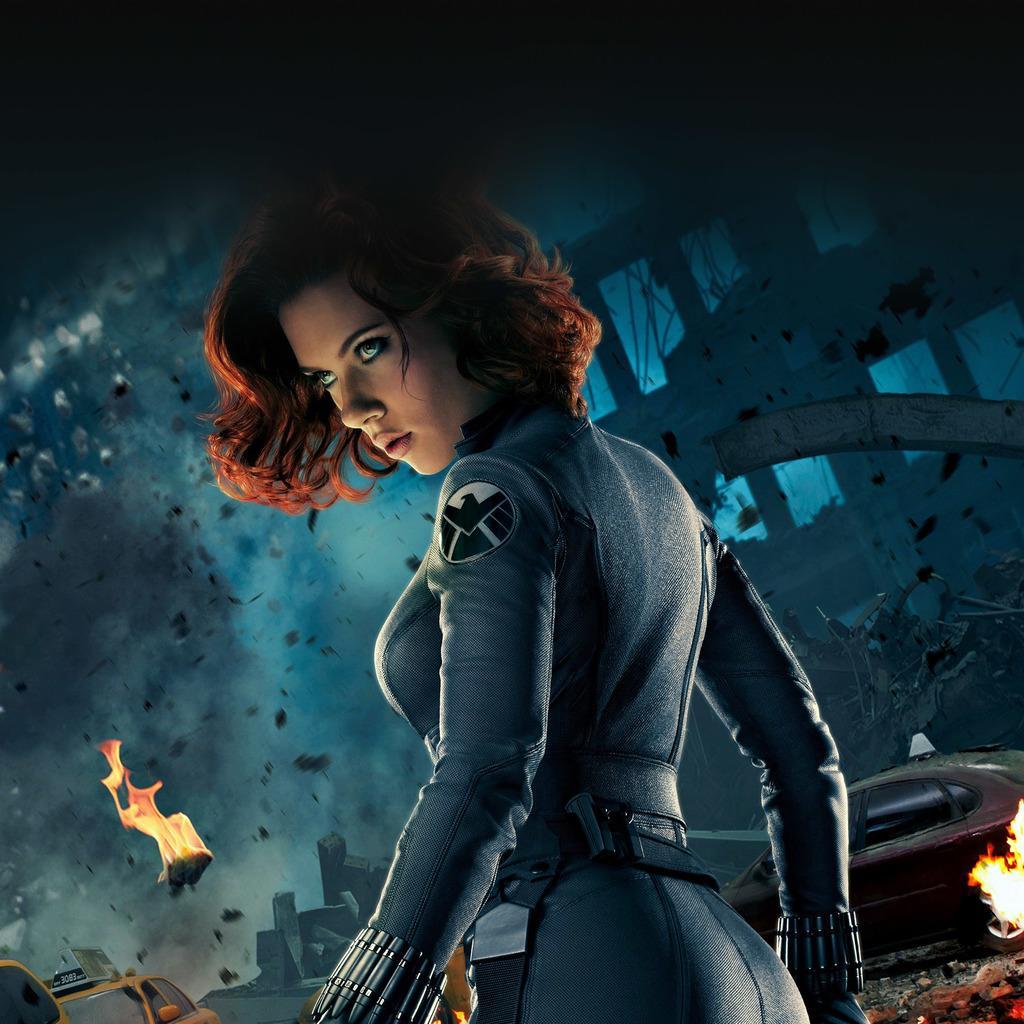Can you describe this image briefly? In this image we can see an animated picture in which a woman is standing and we can also see fire and smoke. 